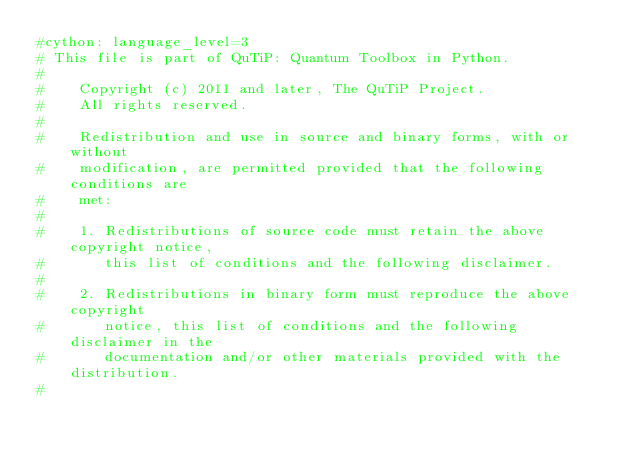Convert code to text. <code><loc_0><loc_0><loc_500><loc_500><_Cython_>#cython: language_level=3
# This file is part of QuTiP: Quantum Toolbox in Python.
#
#    Copyright (c) 2011 and later, The QuTiP Project.
#    All rights reserved.
#
#    Redistribution and use in source and binary forms, with or without
#    modification, are permitted provided that the following conditions are
#    met:
#
#    1. Redistributions of source code must retain the above copyright notice,
#       this list of conditions and the following disclaimer.
#
#    2. Redistributions in binary form must reproduce the above copyright
#       notice, this list of conditions and the following disclaimer in the
#       documentation and/or other materials provided with the distribution.
#</code> 